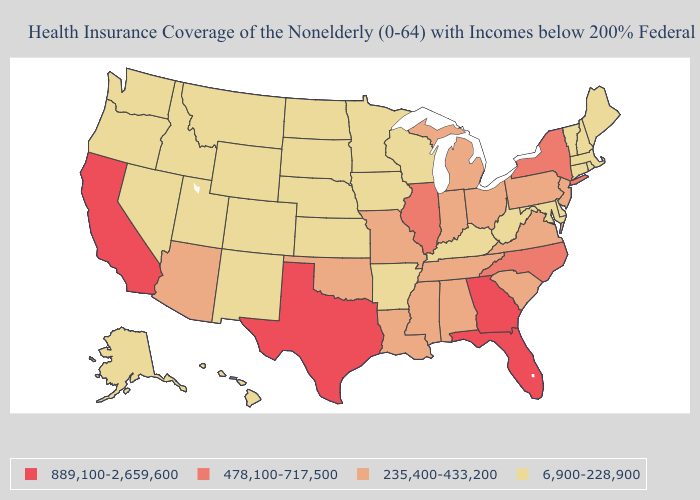What is the highest value in the USA?
Keep it brief. 889,100-2,659,600. What is the highest value in the Northeast ?
Keep it brief. 478,100-717,500. Does the first symbol in the legend represent the smallest category?
Write a very short answer. No. What is the value of South Carolina?
Concise answer only. 235,400-433,200. What is the value of Florida?
Be succinct. 889,100-2,659,600. Does New Hampshire have the same value as Mississippi?
Keep it brief. No. Among the states that border New Mexico , does Texas have the highest value?
Answer briefly. Yes. What is the value of Colorado?
Give a very brief answer. 6,900-228,900. Among the states that border Oregon , does Washington have the lowest value?
Quick response, please. Yes. Name the states that have a value in the range 478,100-717,500?
Be succinct. Illinois, New York, North Carolina. Does the first symbol in the legend represent the smallest category?
Short answer required. No. What is the value of Washington?
Quick response, please. 6,900-228,900. Among the states that border Virginia , does Kentucky have the lowest value?
Short answer required. Yes. Name the states that have a value in the range 235,400-433,200?
Give a very brief answer. Alabama, Arizona, Indiana, Louisiana, Michigan, Mississippi, Missouri, New Jersey, Ohio, Oklahoma, Pennsylvania, South Carolina, Tennessee, Virginia. How many symbols are there in the legend?
Give a very brief answer. 4. 